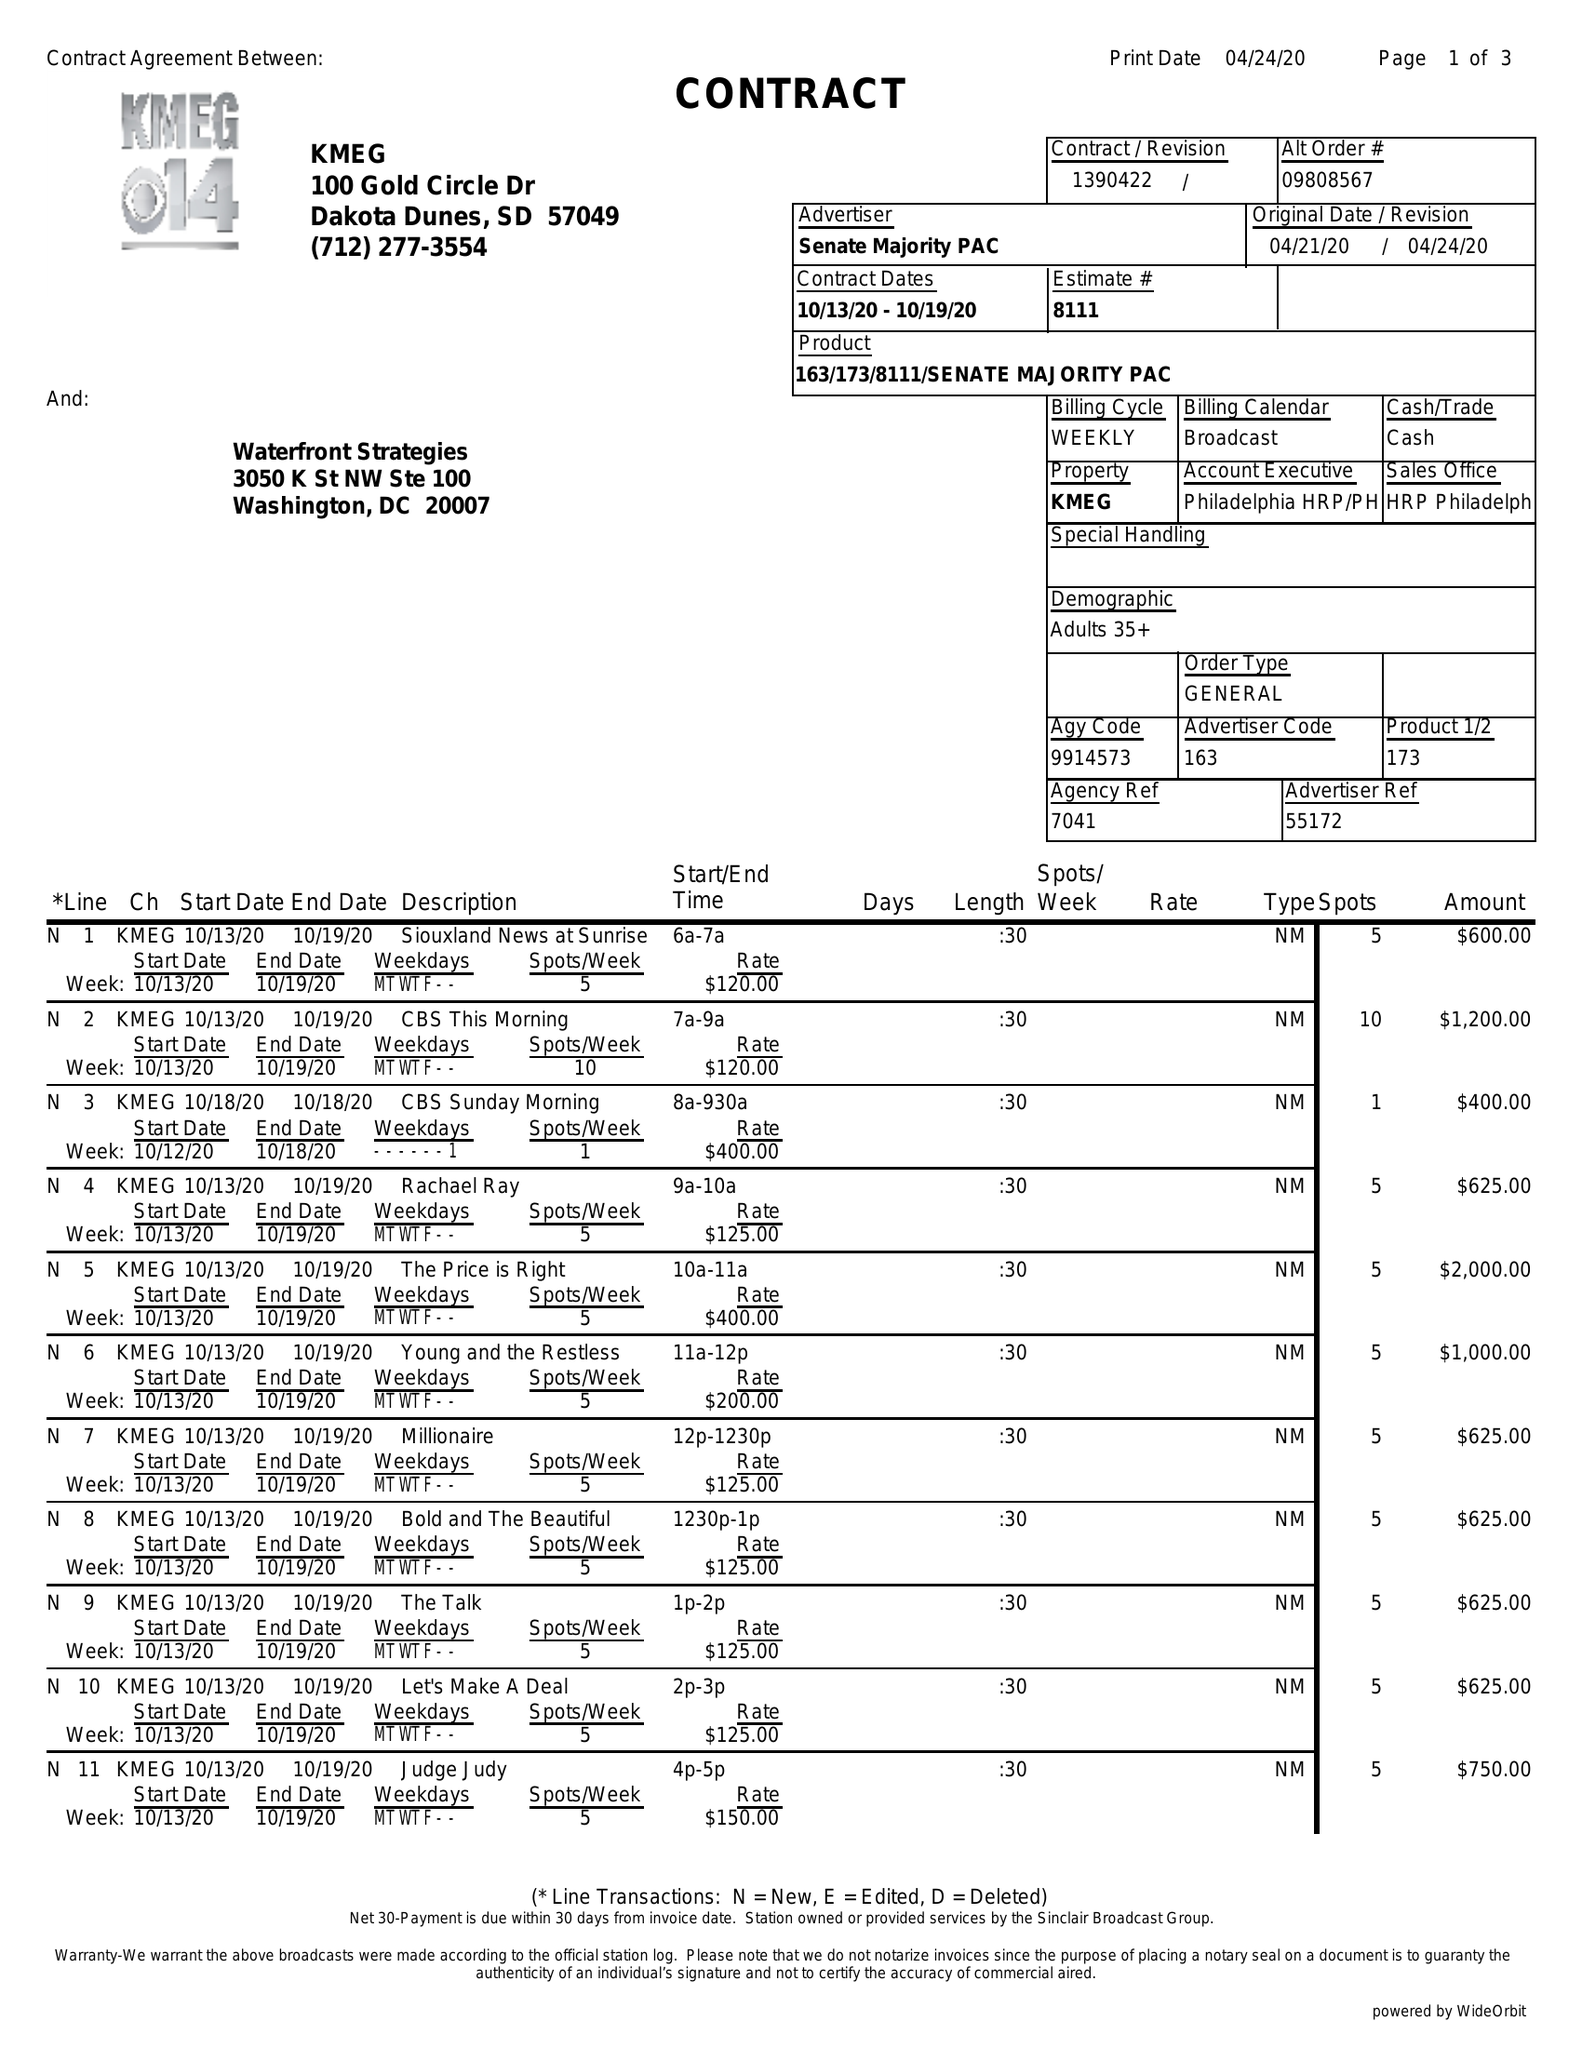What is the value for the gross_amount?
Answer the question using a single word or phrase. 56725.00 